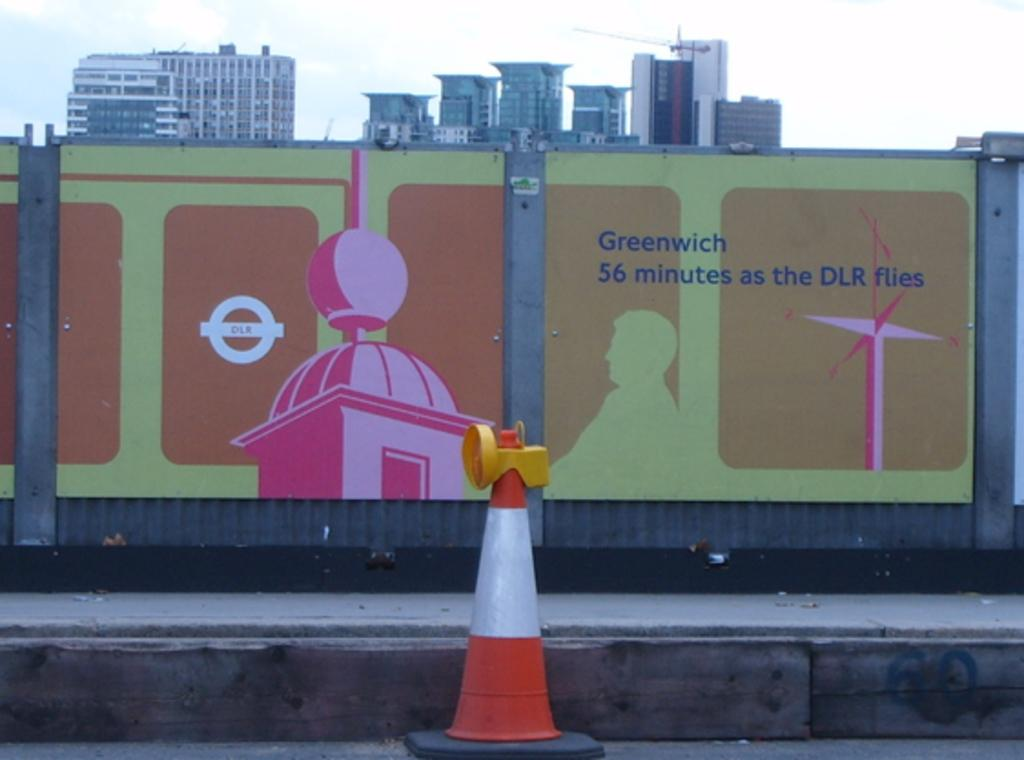<image>
Provide a brief description of the given image. A billboard that says "Greenwich 56 minutes at the DLR Flies." 